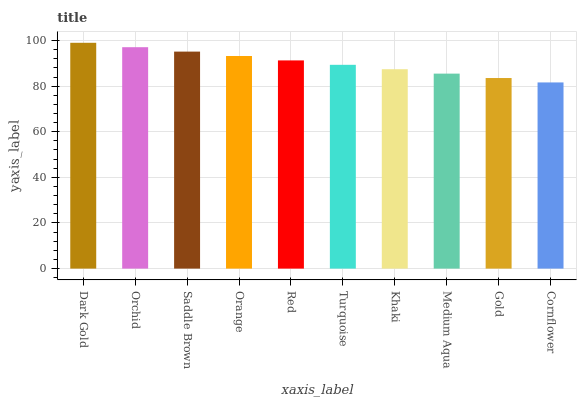Is Cornflower the minimum?
Answer yes or no. Yes. Is Dark Gold the maximum?
Answer yes or no. Yes. Is Orchid the minimum?
Answer yes or no. No. Is Orchid the maximum?
Answer yes or no. No. Is Dark Gold greater than Orchid?
Answer yes or no. Yes. Is Orchid less than Dark Gold?
Answer yes or no. Yes. Is Orchid greater than Dark Gold?
Answer yes or no. No. Is Dark Gold less than Orchid?
Answer yes or no. No. Is Red the high median?
Answer yes or no. Yes. Is Turquoise the low median?
Answer yes or no. Yes. Is Gold the high median?
Answer yes or no. No. Is Gold the low median?
Answer yes or no. No. 